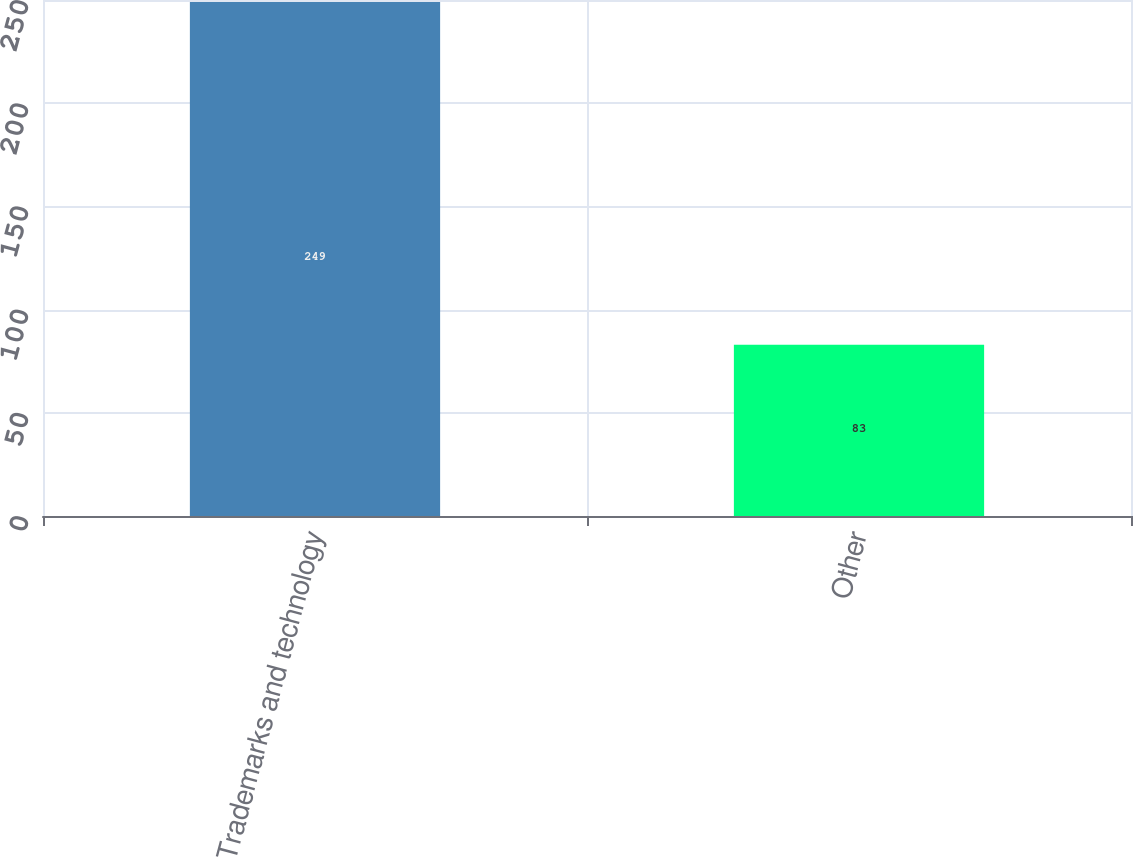Convert chart. <chart><loc_0><loc_0><loc_500><loc_500><bar_chart><fcel>Trademarks and technology<fcel>Other<nl><fcel>249<fcel>83<nl></chart> 